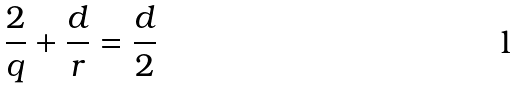<formula> <loc_0><loc_0><loc_500><loc_500>\frac { 2 } { q } + \frac { d } { r } = \frac { d } { 2 }</formula> 